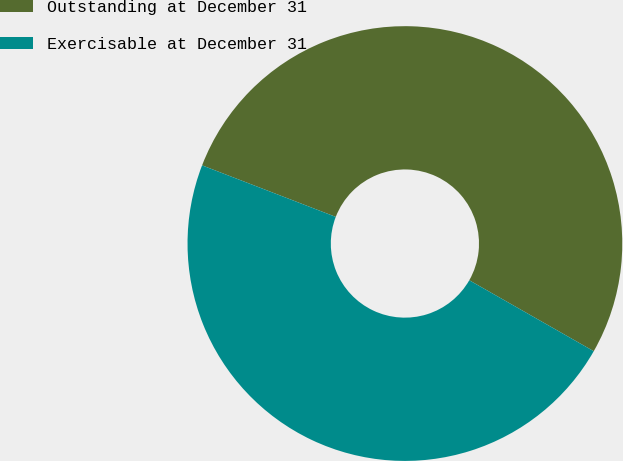<chart> <loc_0><loc_0><loc_500><loc_500><pie_chart><fcel>Outstanding at December 31<fcel>Exercisable at December 31<nl><fcel>52.39%<fcel>47.61%<nl></chart> 